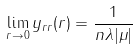Convert formula to latex. <formula><loc_0><loc_0><loc_500><loc_500>\lim _ { r \to 0 } y _ { r r } ( r ) = \frac { 1 } { n \lambda | \mu | }</formula> 